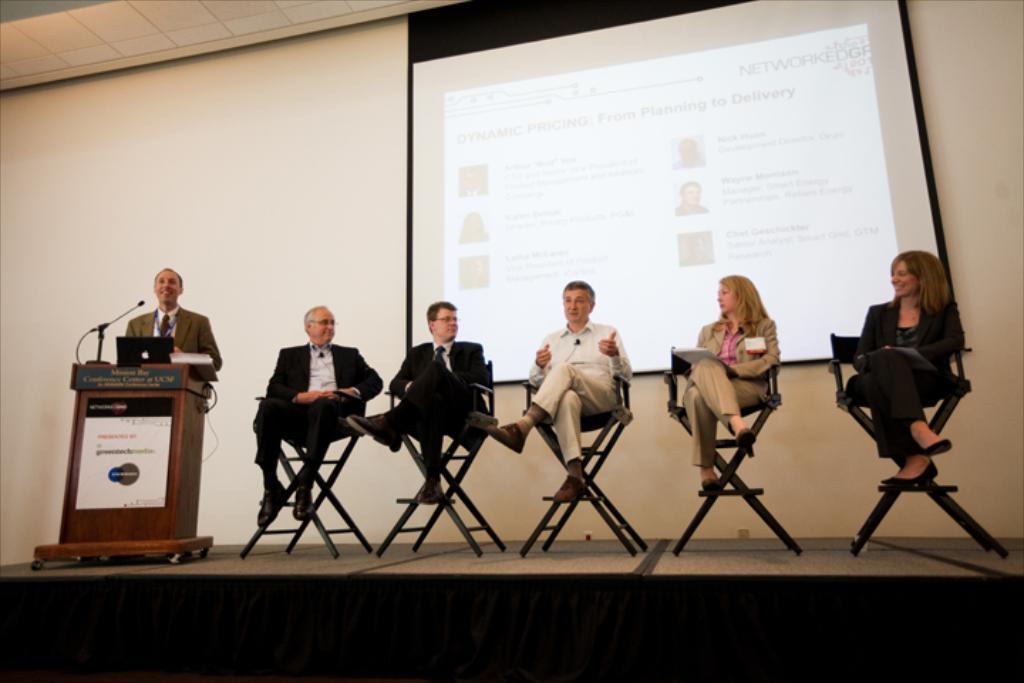Can you describe this image briefly? On the background we can see a screen. this is a wall. here we can see few persons sitting on the chairs. In Front of a podium we can see one man standing in front of a mike and laptop. 